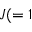Convert formula to latex. <formula><loc_0><loc_0><loc_500><loc_500>J ( = 1</formula> 